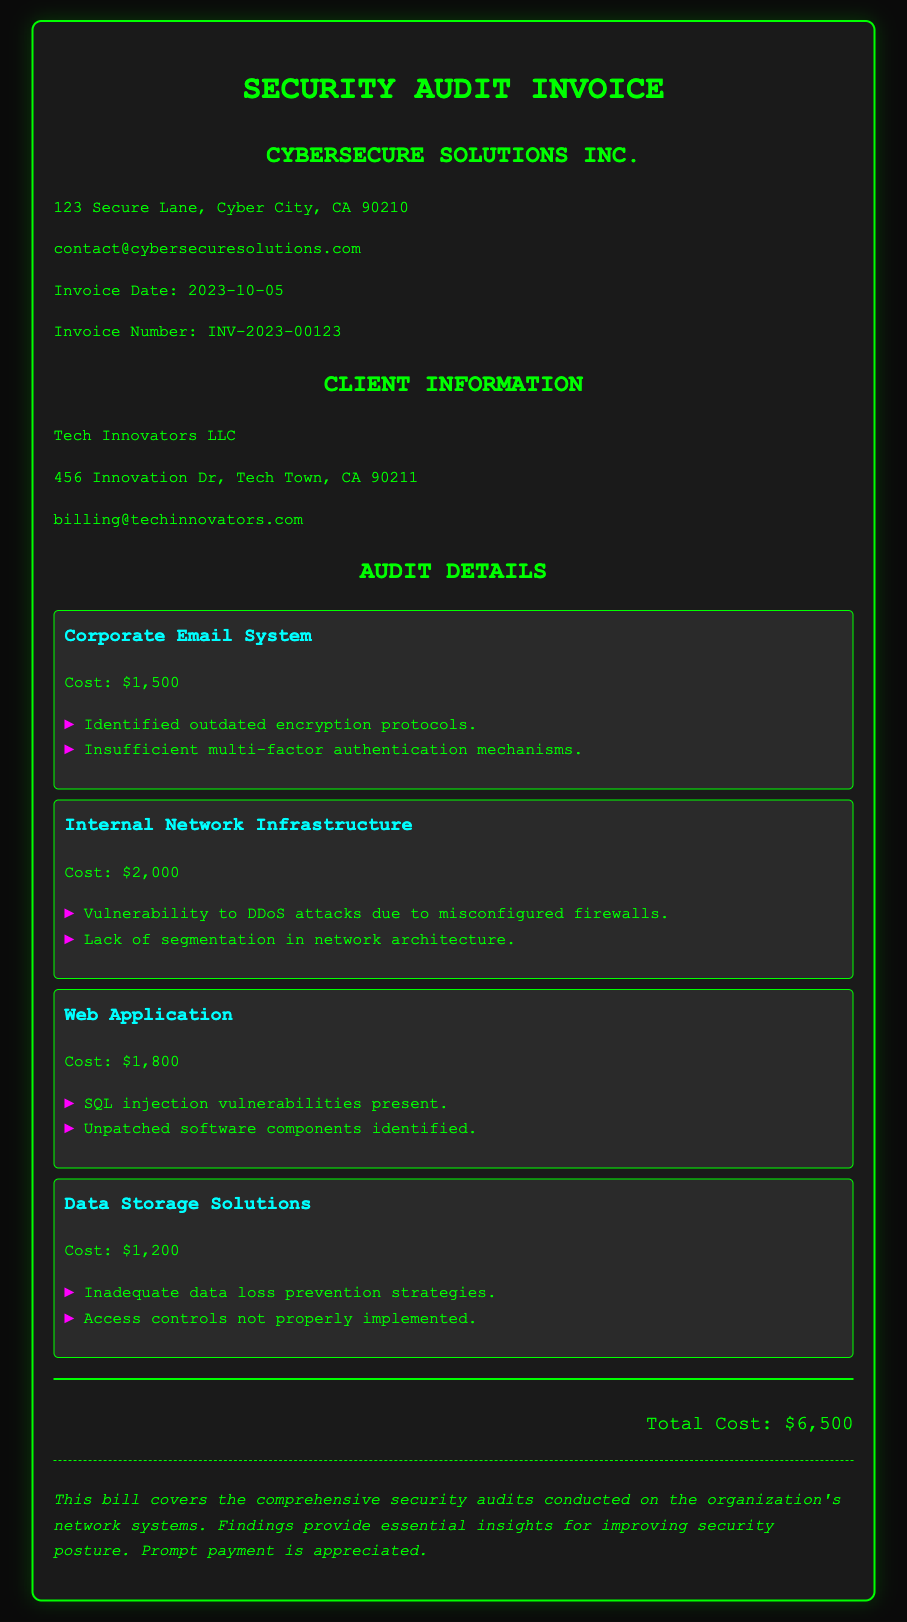What is the invoice number? The invoice number is listed in the document as INV-2023-00123.
Answer: INV-2023-00123 What is the cost for the Corporate Email System? The cost for the Corporate Email System is provided explicitly in the document, which is $1,500.
Answer: $1,500 What were the findings for the Web Application? The findings for the Web Application include vulnerabilities related to SQL injection and unpatched software components, requiring reasoning across multiple details.
Answer: SQL injection vulnerabilities present, unpatched software components identified How many audit items are listed? The document lists each audited system clearly, allowing for straightforward counting of the items, which are four in total.
Answer: 4 What is the total cost of the security audits? The total cost is calculated as the sum of all individual system costs detailed in the document, which totals to $6,500.
Answer: $6,500 What is the date of the invoice? The document provides the invoice date directly, which is 2023-10-05.
Answer: 2023-10-05 Which company conducted the security audits? The document states that CyberSecure Solutions Inc. conducted the audits, making it explicit information retrieval.
Answer: CyberSecure Solutions Inc What main issues were identified in the Internal Network Infrastructure? The main issues outlined in the document specifically note misconfigured firewalls and lack of segmentation, requiring synthesis of information from the audit item.
Answer: Vulnerability to DDoS attacks due to misconfigured firewalls, lack of segmentation in network architecture 